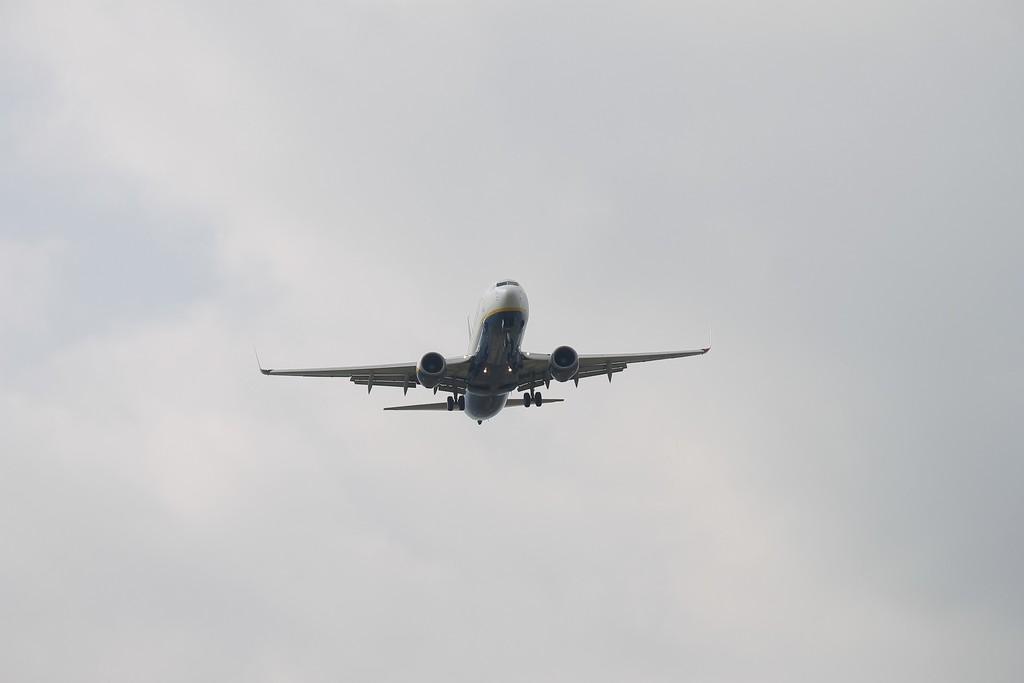Please provide a concise description of this image. In this image I can see an airplane in the air. In the background I can see clouds and the sky. 